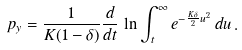<formula> <loc_0><loc_0><loc_500><loc_500>p _ { y } = \frac { 1 } { K ( 1 - \delta ) } \frac { d } { d t } \, \ln \int _ { t } ^ { \infty } e ^ { - \frac { K \delta } { 2 } u ^ { 2 } } \, d u \, .</formula> 